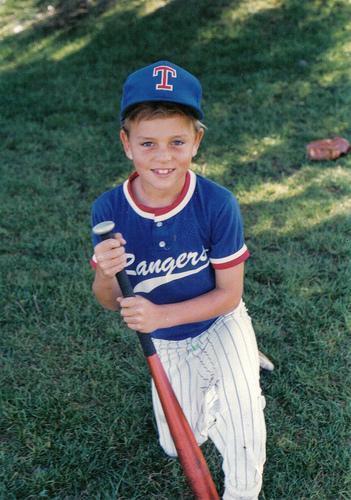How many pizzas are there?
Give a very brief answer. 0. 